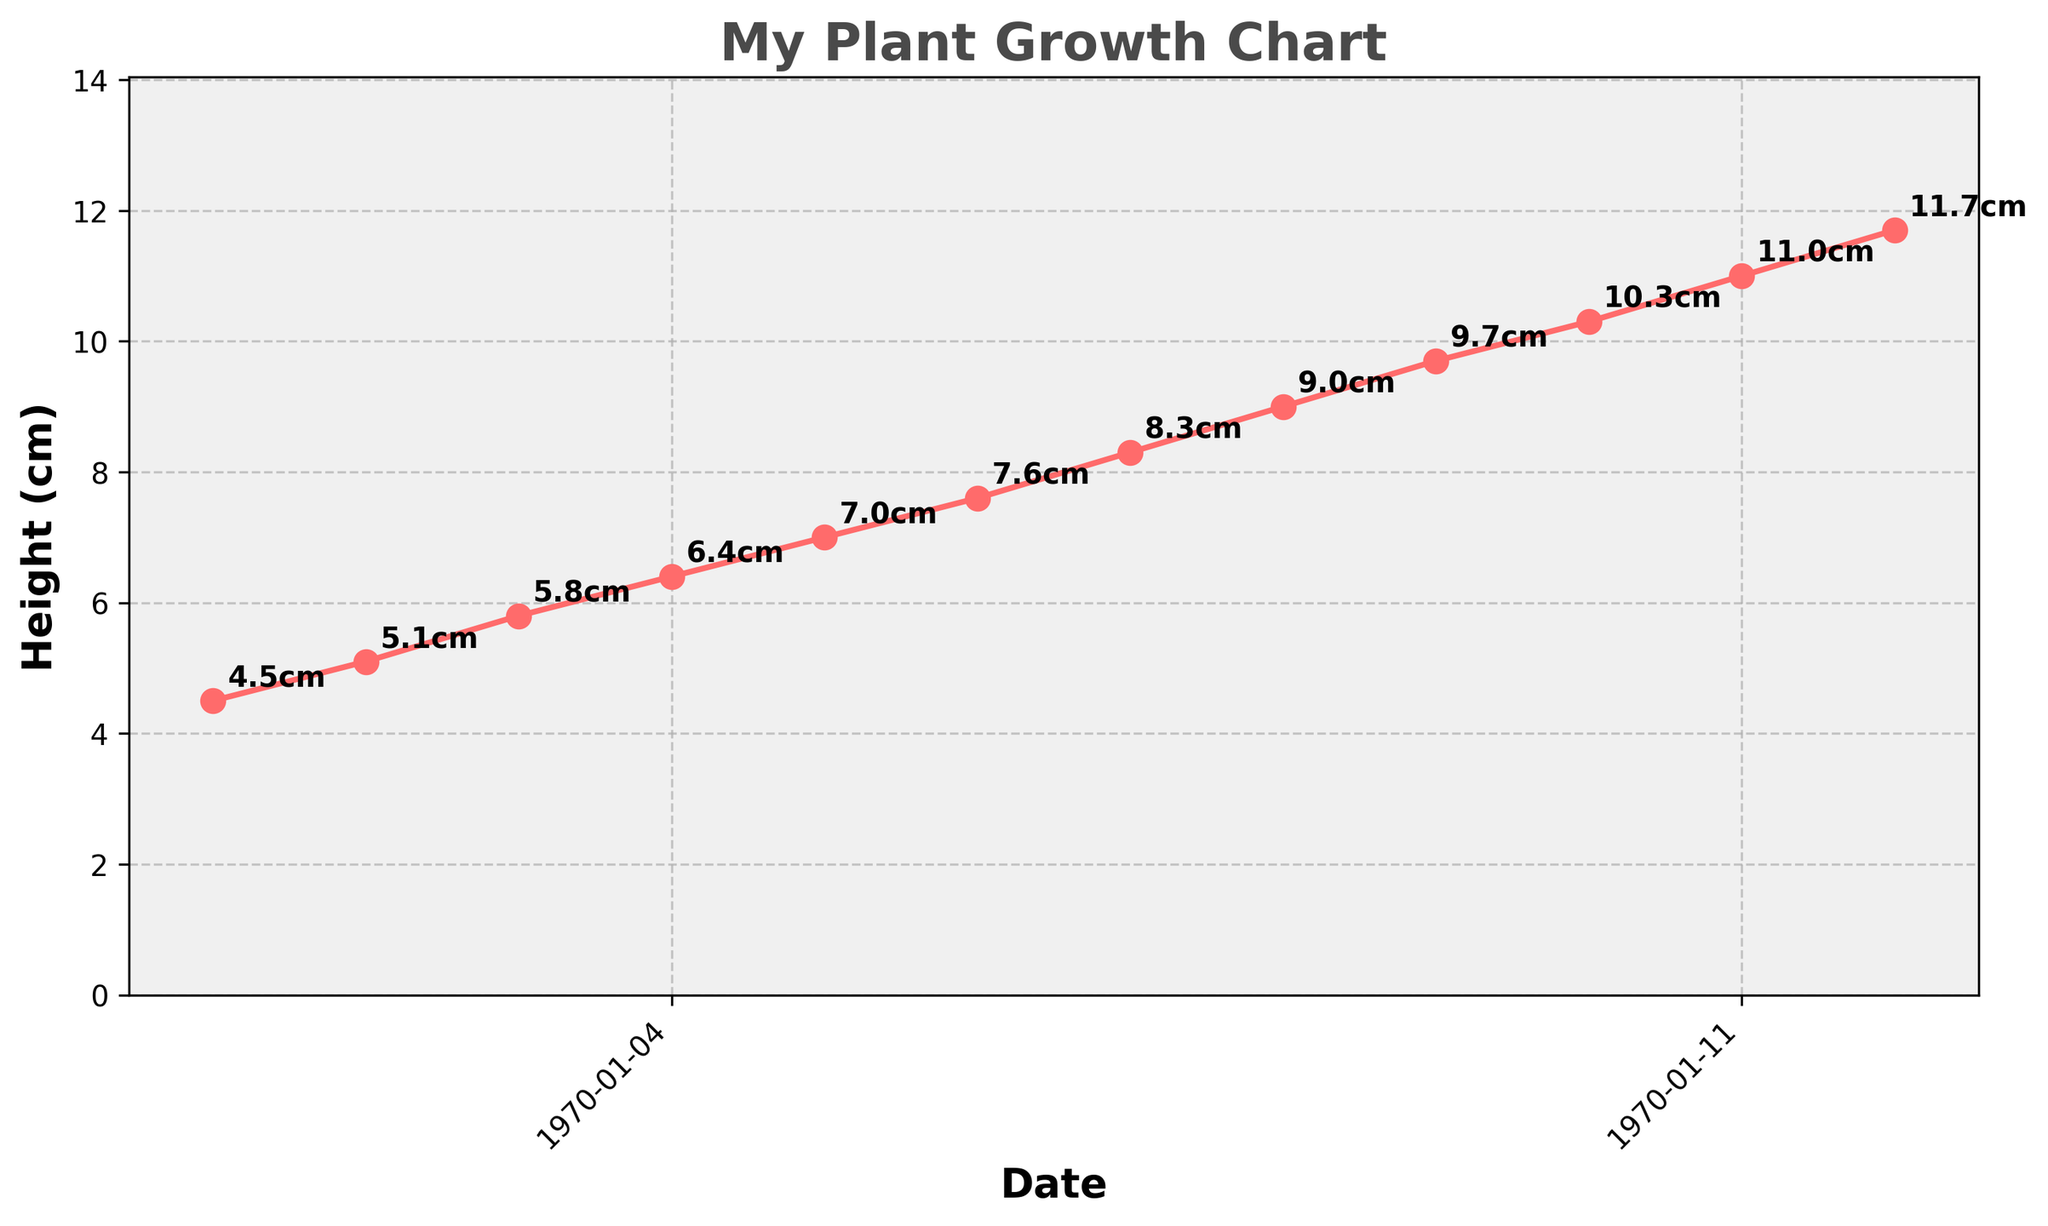What is the title of the chart? The title of the chart is typically found at the top center of the figure. In this case, it says "My Plant Growth Chart".
Answer: My Plant Growth Chart What are the labels of the x-axis and y-axis? The x-axis label is usually at the bottom of the chart, and the y-axis label is on the left side. In this chart, the x-axis label is "Date" and the y-axis label is "Height (cm)".
Answer: Date and Height (cm) Over how many weeks was the plant's height measured? The plant's height was measured from 2023-01-01 to 2023-03-19. Calculating the number of weeks between these dates involves counting the number of data points, which is 12 weeks.
Answer: 12 weeks What is the height of the plant on 2023-02-19? To find the height of the plant on a specific date, locate the corresponding point on the plot. On 2023-02-19, the height is labeled as 9.0 cm.
Answer: 9.0 cm By how much did the plant's height increase from 2023-01-01 to 2023-03-19? To find the increase in height, subtract the initial height on 2023-01-01 from the final height on 2023-03-19. The heights are 4.5 cm and 11.7 cm, respectively. The increase is 11.7 cm - 4.5 cm = 7.2 cm.
Answer: 7.2 cm What was the average weekly height increase of the plant? To compute the average weekly height increase, first find the total height increase over 12 weeks, which is 7.2 cm. Then divide this by the number of weeks, 12. The calculation is 7.2 cm / 12 weeks = 0.6 cm/week.
Answer: 0.6 cm/week On which date did the plant achieve a height of 6.4 cm? Find the data point where the height is 6.4 cm and identify the corresponding date, which is 2023-01-22.
Answer: 2023-01-22 Which week saw the highest growth in plant height? Compare the increases in height from week to week. The largest increase is between 2023-02-12 and 2023-02-19, where the height increased from 8.3 cm to 9.0 cm. This overall increase is 0.7 cm.
Answer: Week of 2023-02-12 to 2023-02-19 How many times did the plant grow by more than 0.5 cm in a week? Calculate the weekly growth by subtracting the height of the previous week from the current week. Count the instances where this value exceeds 0.5 cm. This occurs 7 times: weeks ending 2023-01-08, 2023-01-15, 2023-01-22, 2023-02-05, 2023-02-12, 2023-02-19, and 2023-03-12.
Answer: 7 times What is the color of the line used in the plot? The color of the line can be identified from the visual information. In this chart, the line is colored a shade of red.
Answer: Red 